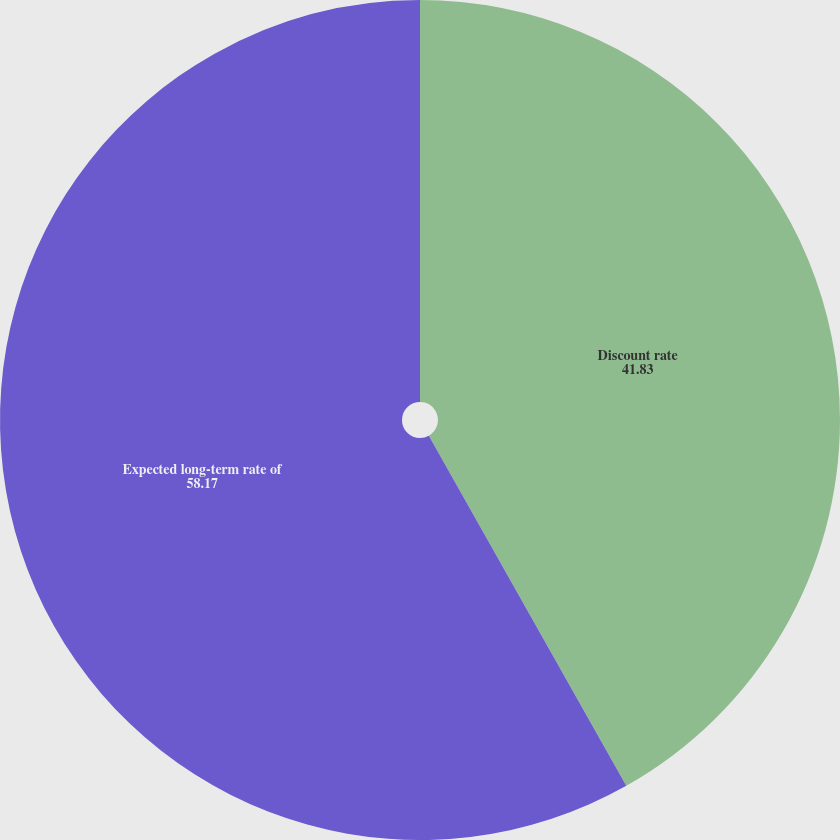Convert chart. <chart><loc_0><loc_0><loc_500><loc_500><pie_chart><fcel>Discount rate<fcel>Expected long-term rate of<nl><fcel>41.83%<fcel>58.17%<nl></chart> 